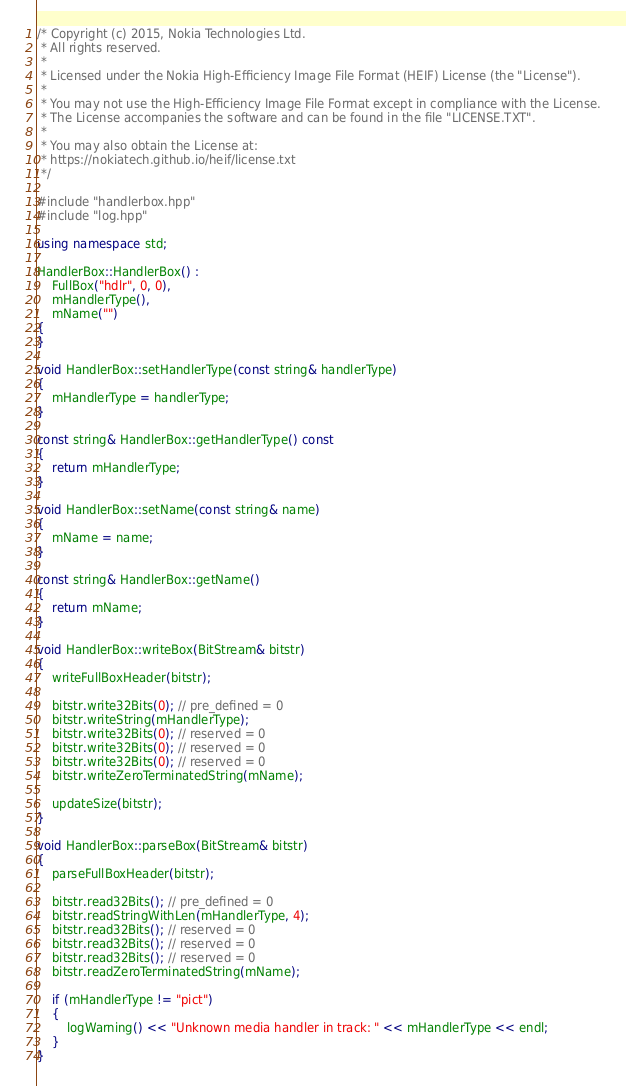Convert code to text. <code><loc_0><loc_0><loc_500><loc_500><_C++_>/* Copyright (c) 2015, Nokia Technologies Ltd.
 * All rights reserved.
 *
 * Licensed under the Nokia High-Efficiency Image File Format (HEIF) License (the "License").
 *
 * You may not use the High-Efficiency Image File Format except in compliance with the License.
 * The License accompanies the software and can be found in the file "LICENSE.TXT".
 *
 * You may also obtain the License at:
 * https://nokiatech.github.io/heif/license.txt
 */

#include "handlerbox.hpp"
#include "log.hpp"

using namespace std;

HandlerBox::HandlerBox() :
    FullBox("hdlr", 0, 0),
    mHandlerType(),
    mName("")
{
}

void HandlerBox::setHandlerType(const string& handlerType)
{
    mHandlerType = handlerType;
}

const string& HandlerBox::getHandlerType() const
{
    return mHandlerType;
}

void HandlerBox::setName(const string& name)
{
    mName = name;
}

const string& HandlerBox::getName()
{
    return mName;
}

void HandlerBox::writeBox(BitStream& bitstr)
{
    writeFullBoxHeader(bitstr);

    bitstr.write32Bits(0); // pre_defined = 0
    bitstr.writeString(mHandlerType);
    bitstr.write32Bits(0); // reserved = 0
    bitstr.write32Bits(0); // reserved = 0
    bitstr.write32Bits(0); // reserved = 0
    bitstr.writeZeroTerminatedString(mName);

    updateSize(bitstr);
}

void HandlerBox::parseBox(BitStream& bitstr)
{
    parseFullBoxHeader(bitstr);

    bitstr.read32Bits(); // pre_defined = 0
    bitstr.readStringWithLen(mHandlerType, 4);
    bitstr.read32Bits(); // reserved = 0
    bitstr.read32Bits(); // reserved = 0
    bitstr.read32Bits(); // reserved = 0
    bitstr.readZeroTerminatedString(mName);

    if (mHandlerType != "pict")
    {
        logWarning() << "Unknown media handler in track: " << mHandlerType << endl;
    }
}
</code> 